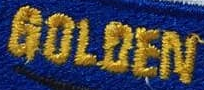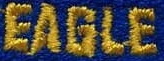What text is displayed in these images sequentially, separated by a semicolon? GOLOEN; EAGLE 